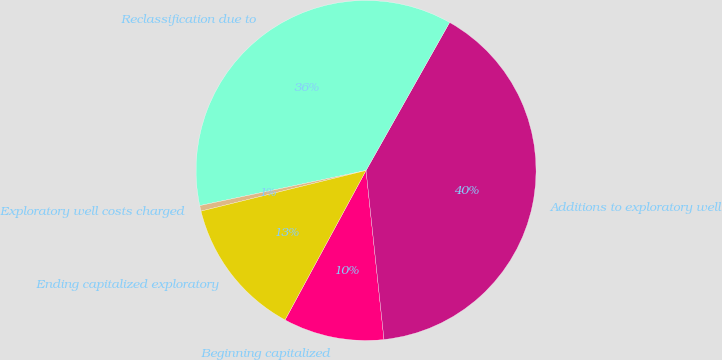Convert chart. <chart><loc_0><loc_0><loc_500><loc_500><pie_chart><fcel>Beginning capitalized<fcel>Additions to exploratory well<fcel>Reclassification due to<fcel>Exploratory well costs charged<fcel>Ending capitalized exploratory<nl><fcel>9.59%<fcel>40.14%<fcel>36.49%<fcel>0.53%<fcel>13.25%<nl></chart> 